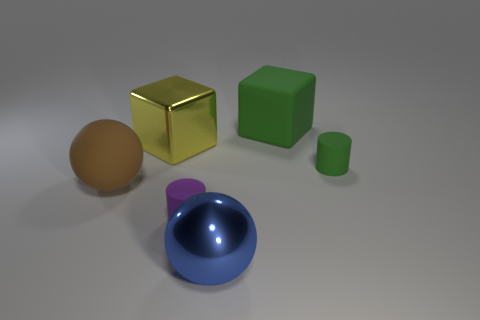What size is the rubber object that is on the right side of the green matte cube?
Keep it short and to the point. Small. What number of tiny matte objects are behind the rubber cylinder behind the large ball to the left of the large yellow metallic thing?
Provide a short and direct response. 0. Is the rubber sphere the same color as the big matte block?
Your answer should be very brief. No. How many things are in front of the large matte cube and to the right of the large brown matte object?
Offer a terse response. 4. There is a metal thing that is left of the blue ball; what is its shape?
Offer a terse response. Cube. Are there fewer rubber blocks left of the big green matte block than big balls behind the large brown matte thing?
Provide a succinct answer. No. Do the cube that is left of the purple matte cylinder and the object to the left of the large yellow shiny block have the same material?
Make the answer very short. No. What is the shape of the small green matte thing?
Give a very brief answer. Cylinder. Are there more spheres that are behind the blue shiny ball than tiny cylinders to the left of the purple matte cylinder?
Give a very brief answer. Yes. Is the shape of the metal thing on the right side of the yellow object the same as the big matte thing in front of the big yellow block?
Provide a short and direct response. Yes. 